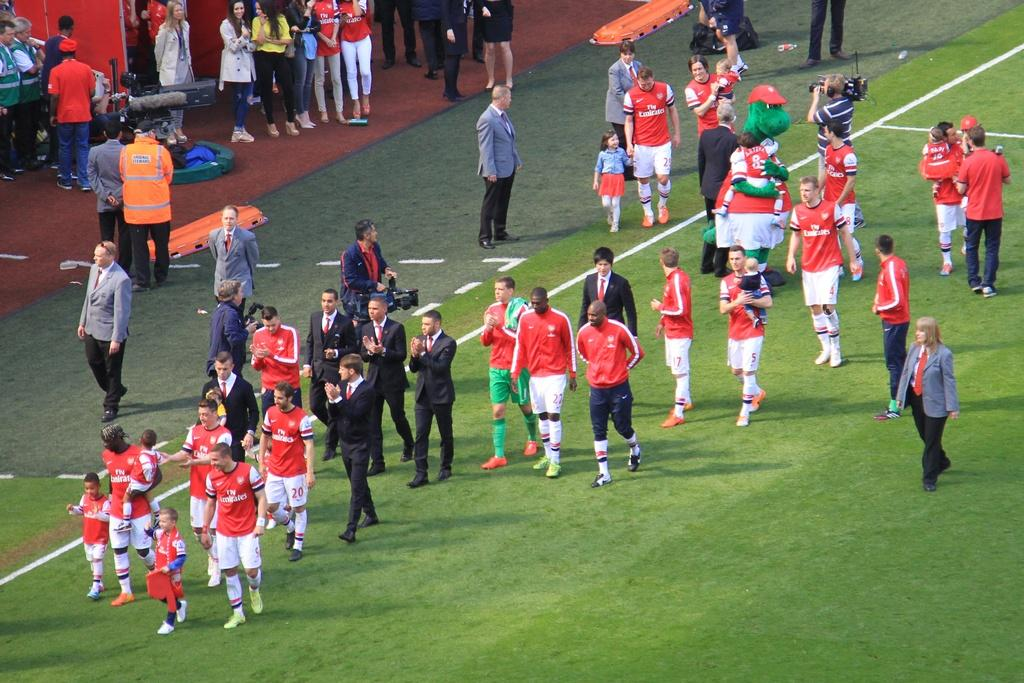<image>
Share a concise interpretation of the image provided. The Fly Emirates soccer team walks off the field with the coaches and some children. 